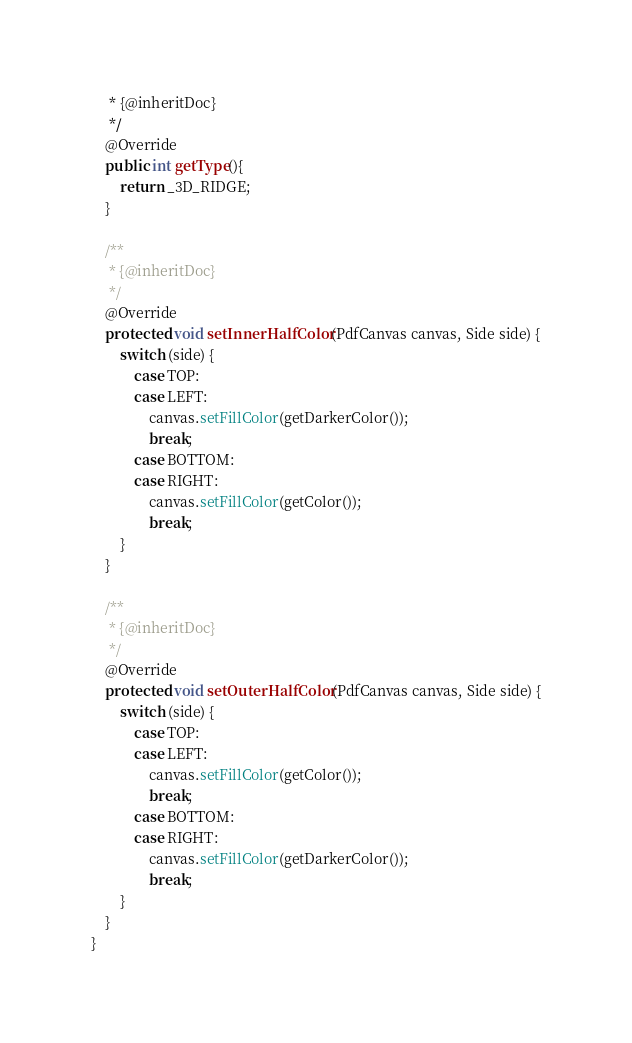Convert code to text. <code><loc_0><loc_0><loc_500><loc_500><_Java_>     * {@inheritDoc}
     */
    @Override
    public int getType(){
        return _3D_RIDGE;
    }

    /**
     * {@inheritDoc}
     */
    @Override
    protected void setInnerHalfColor(PdfCanvas canvas, Side side) {
        switch (side) {
            case TOP:
            case LEFT:
                canvas.setFillColor(getDarkerColor());
                break;
            case BOTTOM:
            case RIGHT:
                canvas.setFillColor(getColor());
                break;
        }
    }

    /**
     * {@inheritDoc}
     */
    @Override
    protected void setOuterHalfColor(PdfCanvas canvas, Side side) {
        switch (side) {
            case TOP:
            case LEFT:
                canvas.setFillColor(getColor());
                break;
            case BOTTOM:
            case RIGHT:
                canvas.setFillColor(getDarkerColor());
                break;
        }
    }
}
</code> 